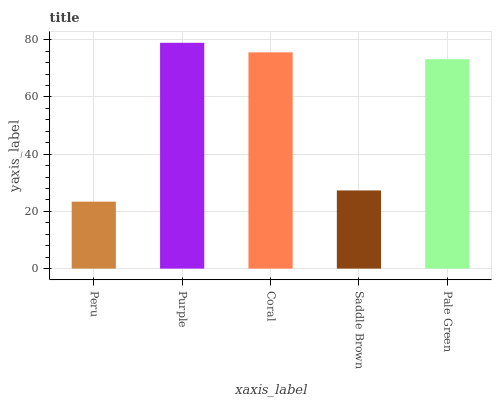Is Peru the minimum?
Answer yes or no. Yes. Is Purple the maximum?
Answer yes or no. Yes. Is Coral the minimum?
Answer yes or no. No. Is Coral the maximum?
Answer yes or no. No. Is Purple greater than Coral?
Answer yes or no. Yes. Is Coral less than Purple?
Answer yes or no. Yes. Is Coral greater than Purple?
Answer yes or no. No. Is Purple less than Coral?
Answer yes or no. No. Is Pale Green the high median?
Answer yes or no. Yes. Is Pale Green the low median?
Answer yes or no. Yes. Is Saddle Brown the high median?
Answer yes or no. No. Is Coral the low median?
Answer yes or no. No. 